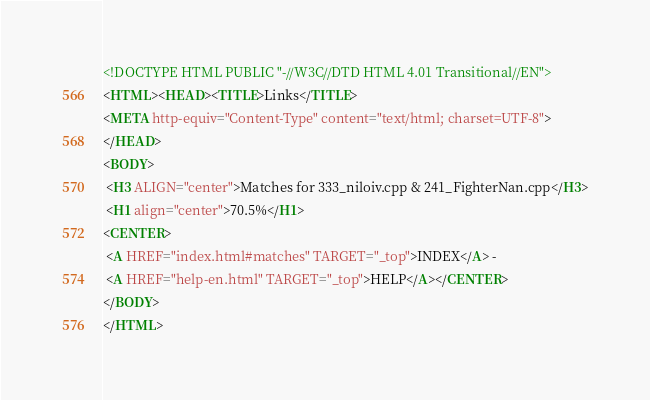Convert code to text. <code><loc_0><loc_0><loc_500><loc_500><_HTML_><!DOCTYPE HTML PUBLIC "-//W3C//DTD HTML 4.01 Transitional//EN">
<HTML><HEAD><TITLE>Links</TITLE>
<META http-equiv="Content-Type" content="text/html; charset=UTF-8">
</HEAD>
<BODY>
 <H3 ALIGN="center">Matches for 333_niloiv.cpp & 241_FighterNan.cpp</H3>
 <H1 align="center">70.5%</H1>
<CENTER>
 <A HREF="index.html#matches" TARGET="_top">INDEX</A> - 
 <A HREF="help-en.html" TARGET="_top">HELP</A></CENTER>
</BODY>
</HTML>
</code> 